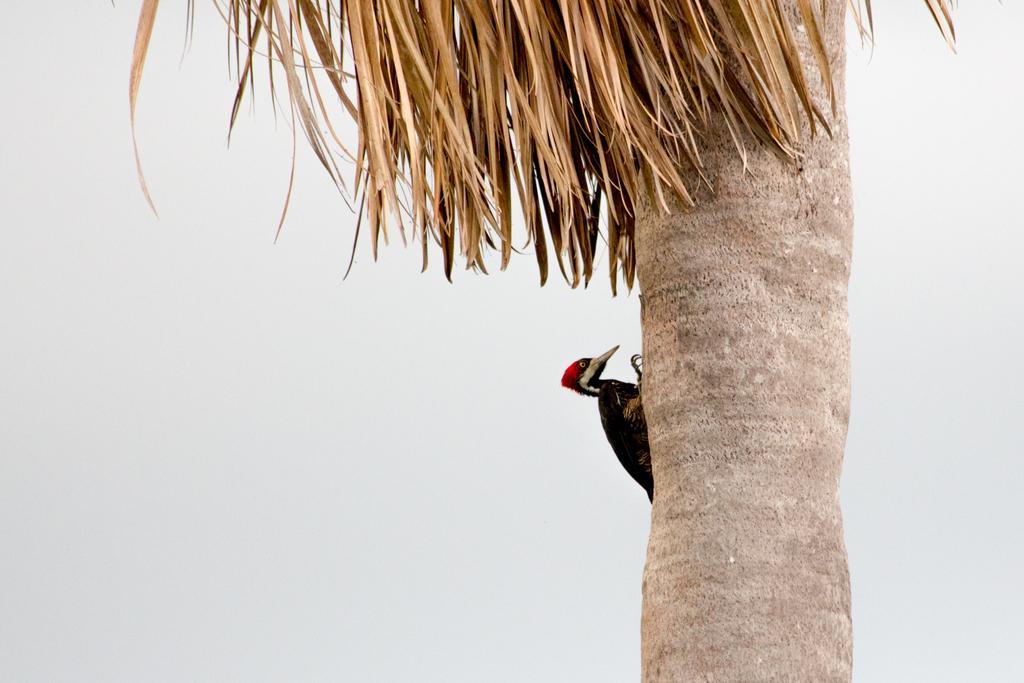How would you summarize this image in a sentence or two? In this picture there is a bird on the tree. In the back I can see the sky and clouds. 